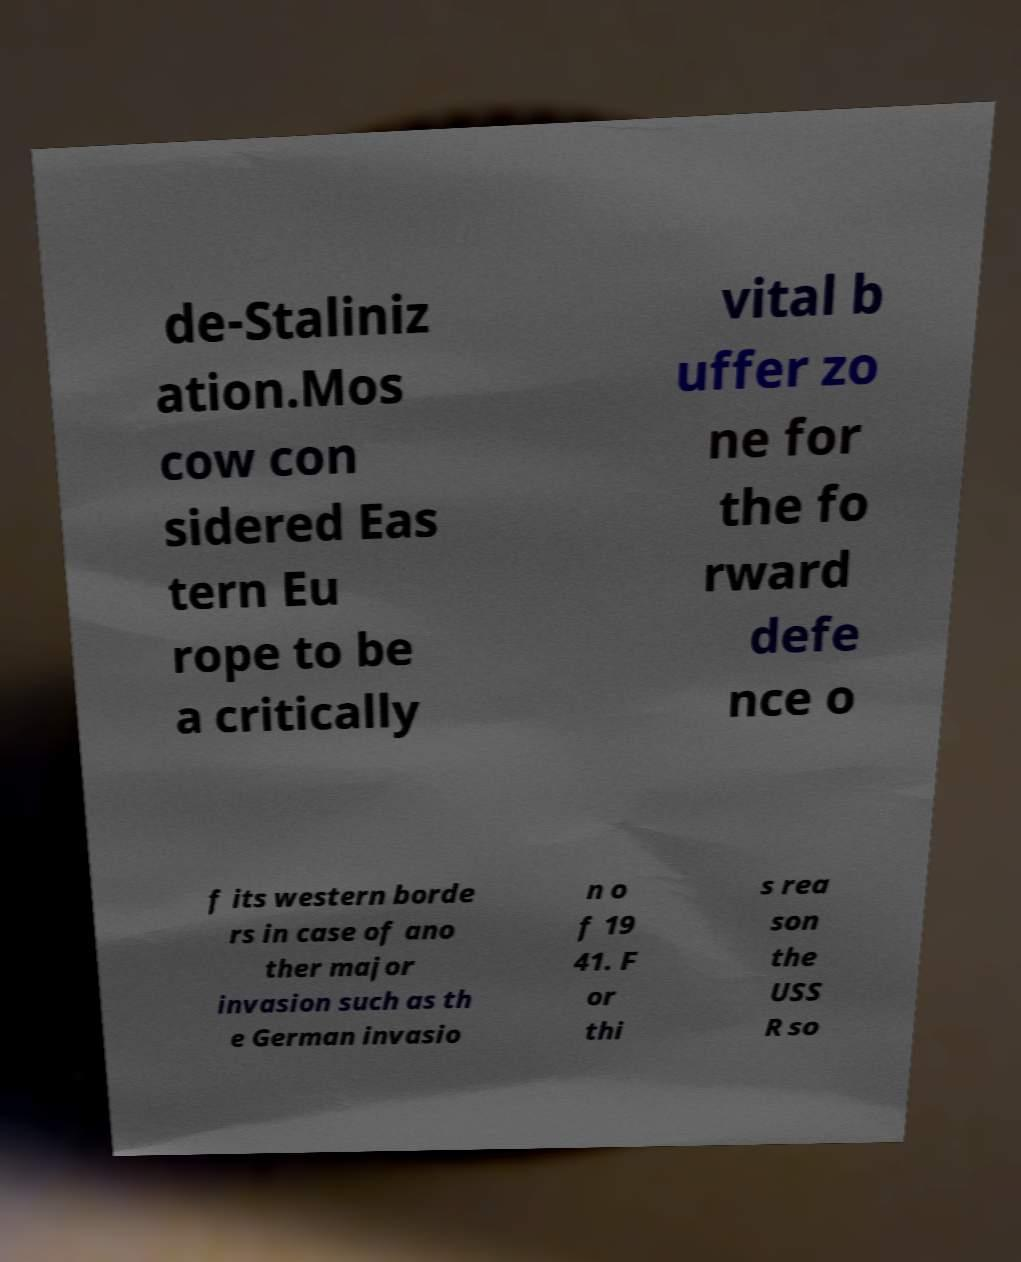Please read and relay the text visible in this image. What does it say? de-Staliniz ation.Mos cow con sidered Eas tern Eu rope to be a critically vital b uffer zo ne for the fo rward defe nce o f its western borde rs in case of ano ther major invasion such as th e German invasio n o f 19 41. F or thi s rea son the USS R so 